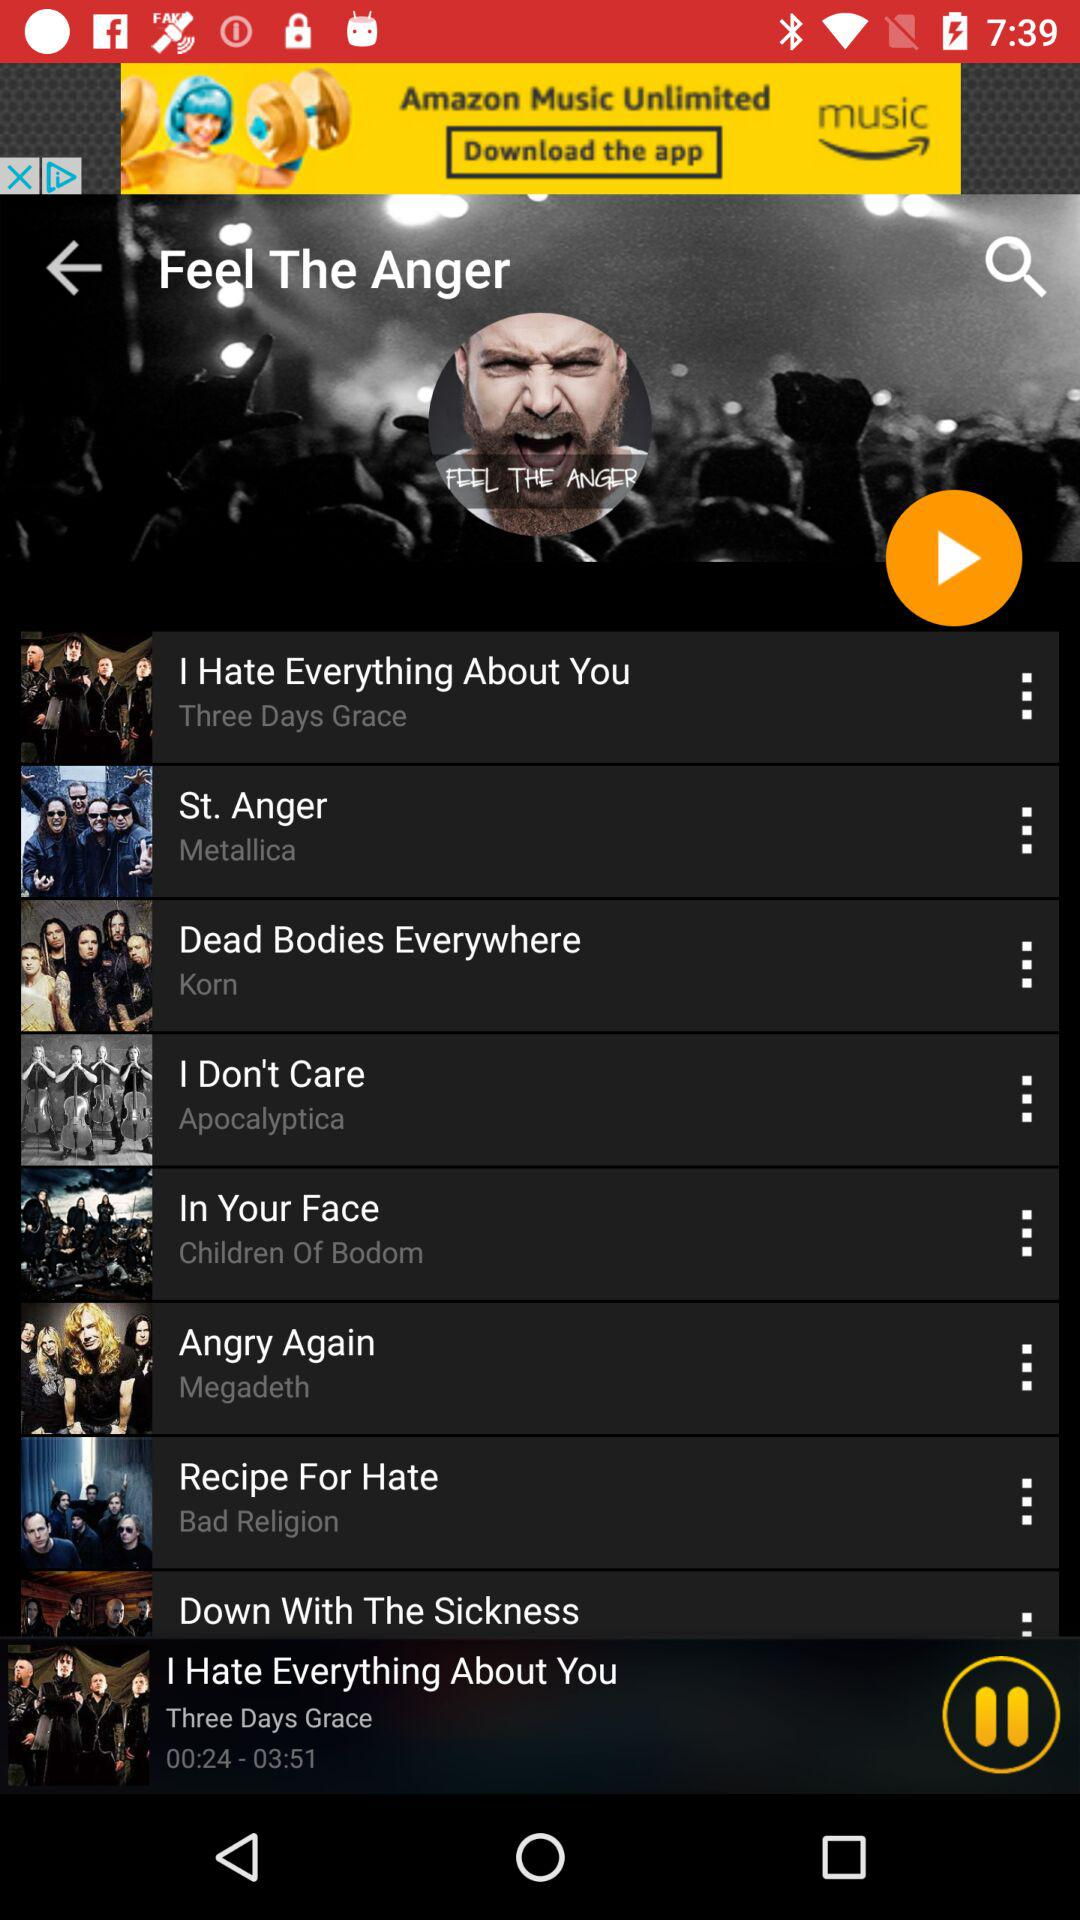What is the duration of the song "I Hate Everything About You"? The duration of the song is 3 minutes and 51 seconds. 